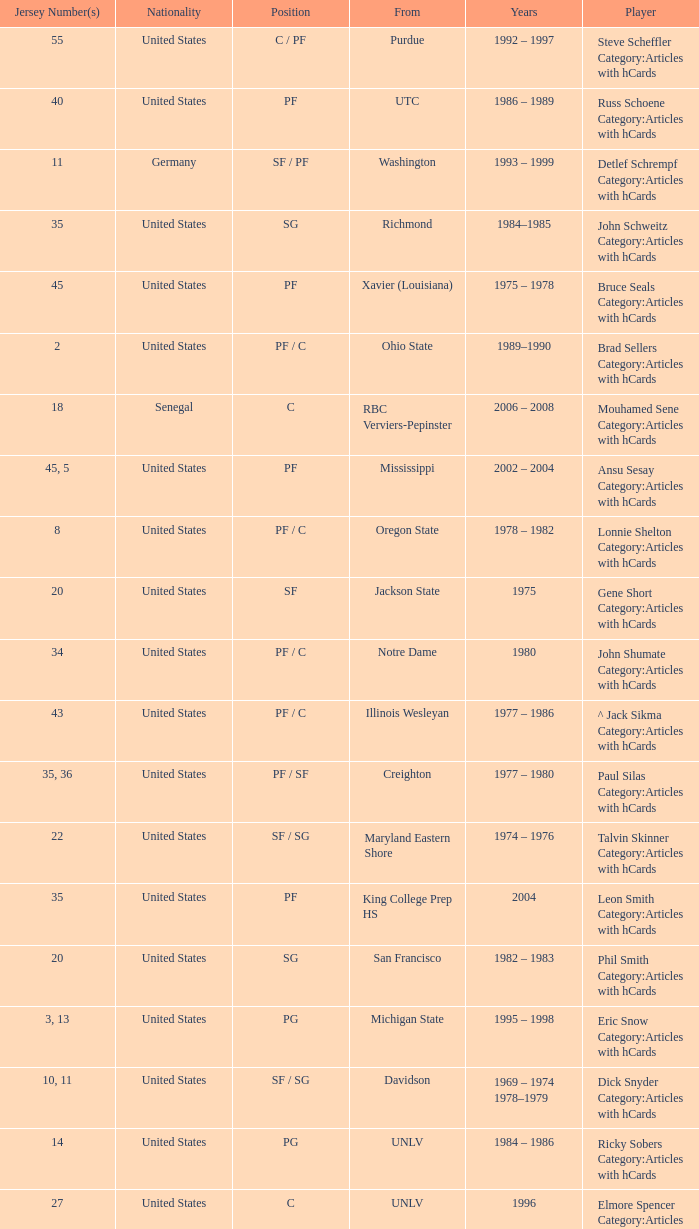Who wears the jersey number 20 and has the position of SG? Phil Smith Category:Articles with hCards, Jon Sundvold Category:Articles with hCards. 